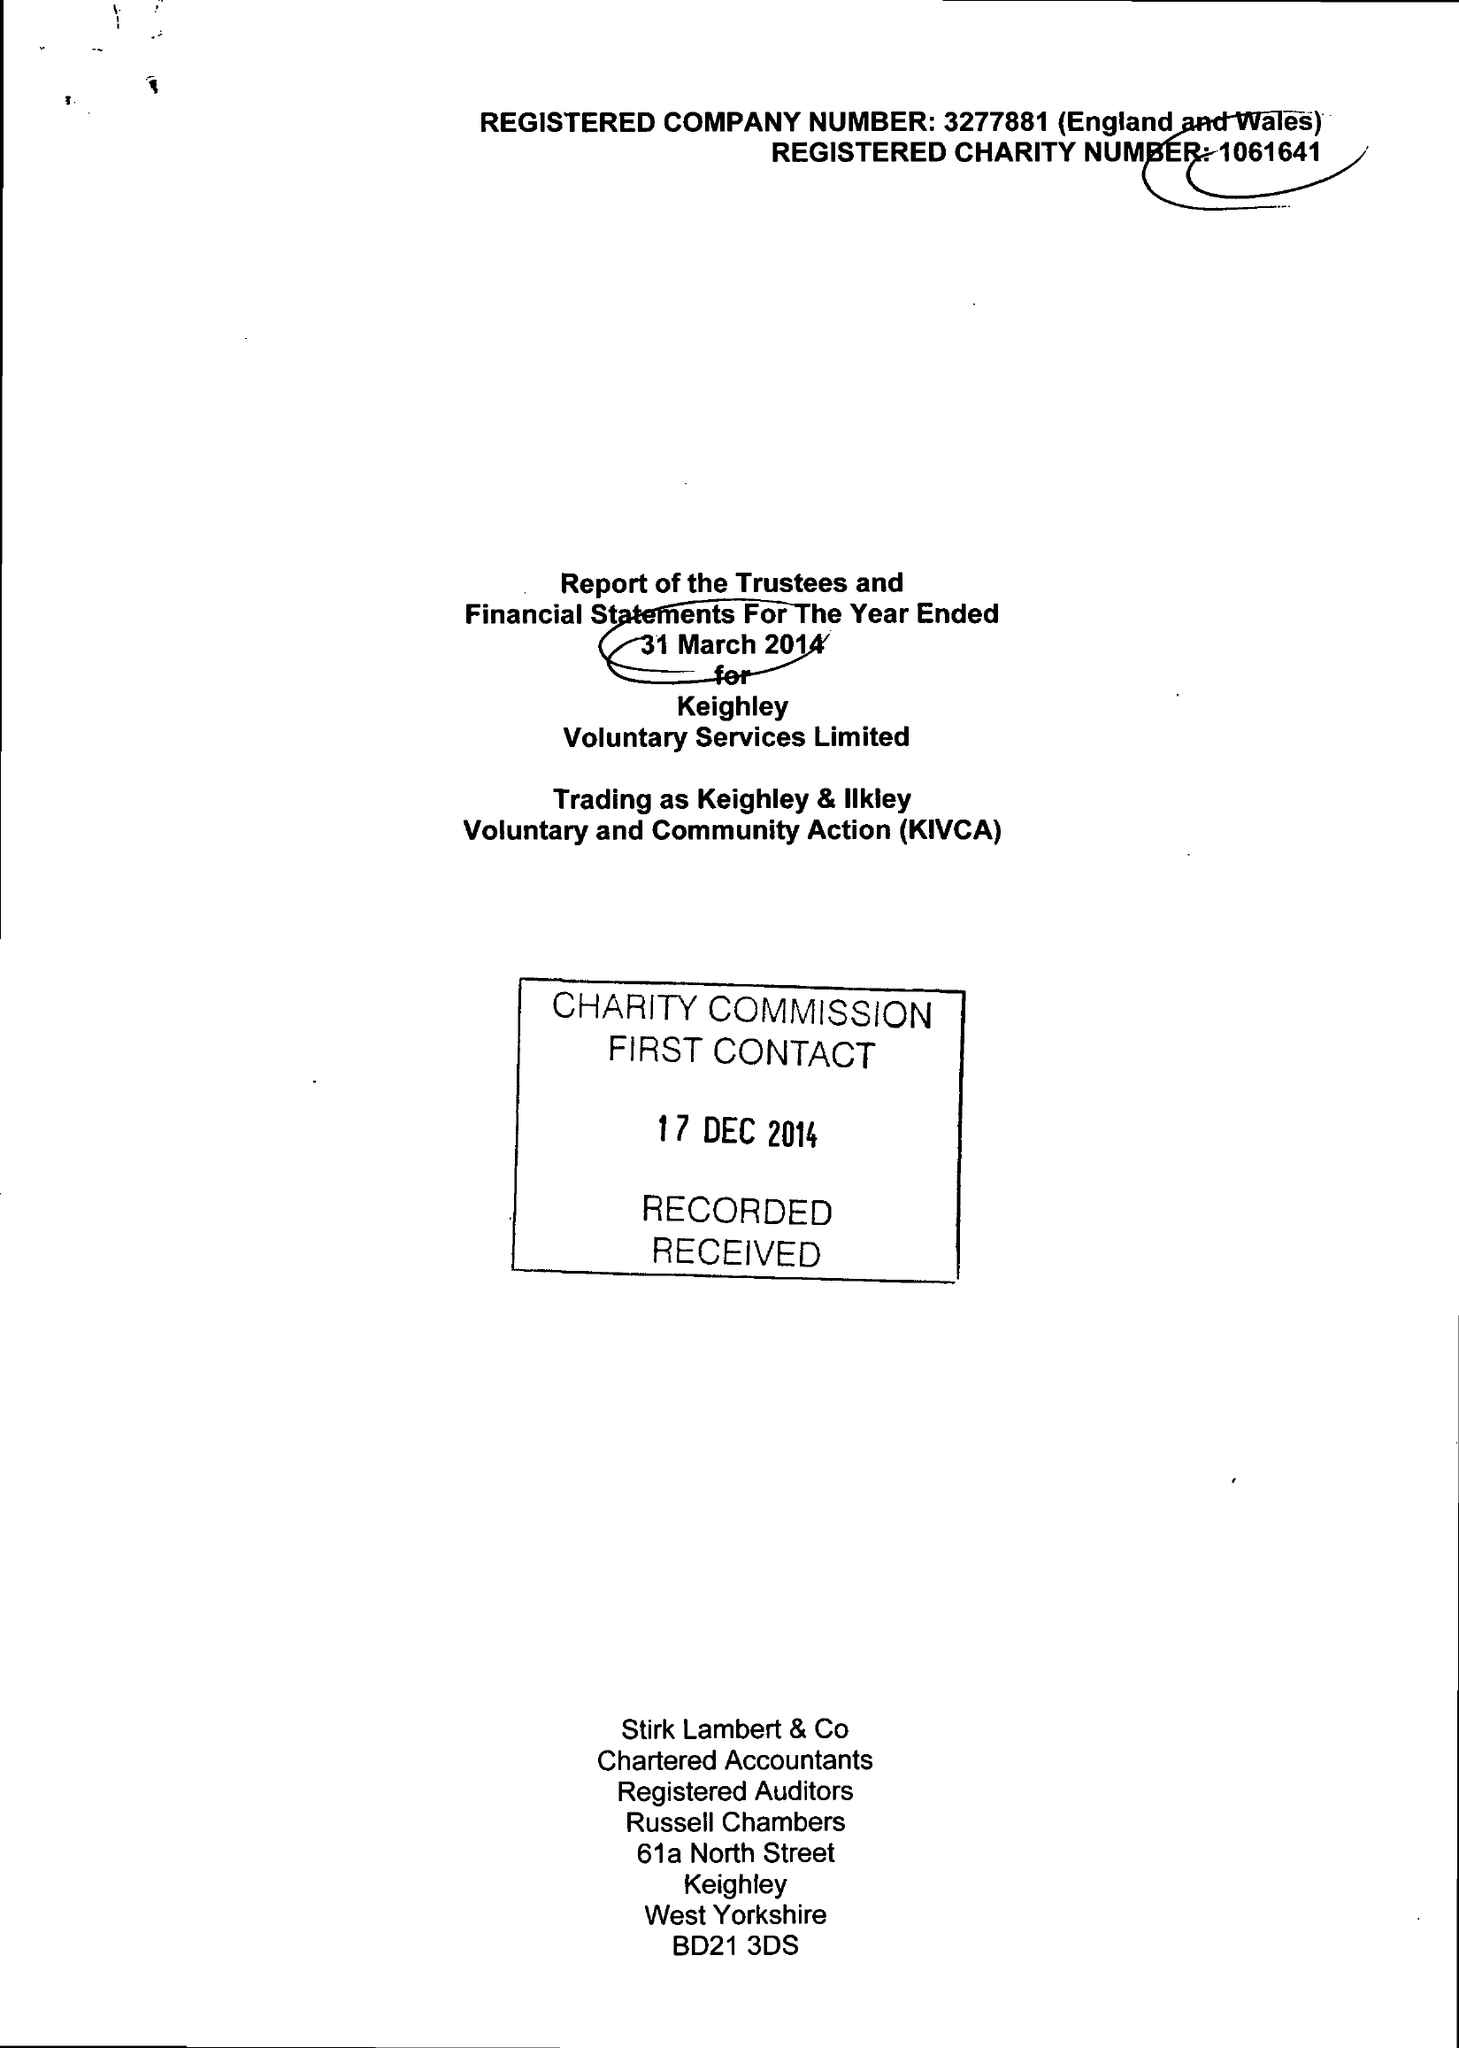What is the value for the charity_name?
Answer the question using a single word or phrase. Keighley Voluntary Service Ltd. 